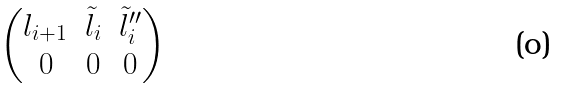<formula> <loc_0><loc_0><loc_500><loc_500>\begin{pmatrix} l _ { i + 1 } & \tilde { l } _ { i } & \tilde { l } _ { i } ^ { \prime \prime } \\ 0 & 0 & 0 \end{pmatrix}</formula> 